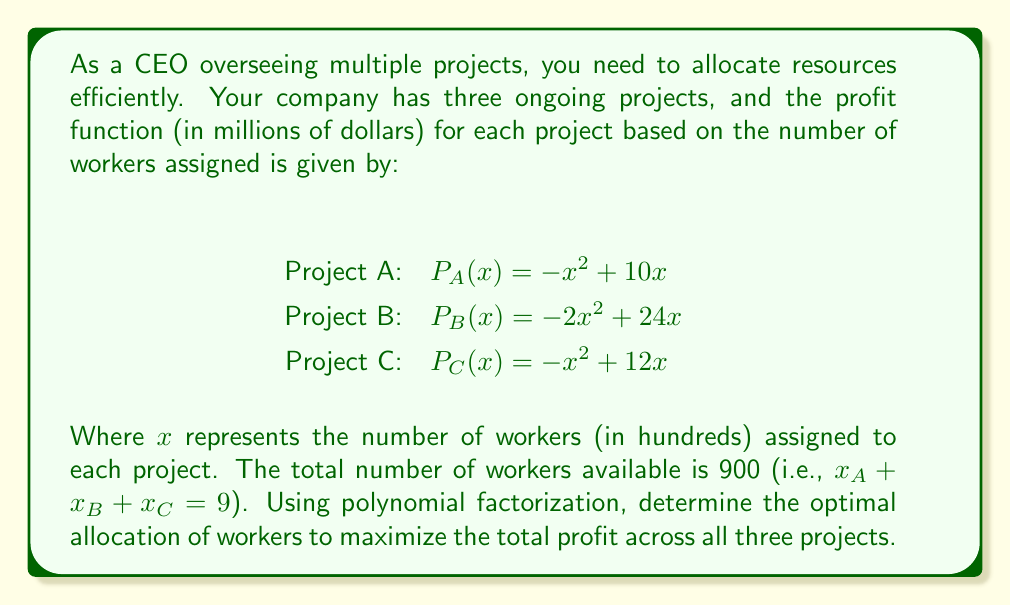Solve this math problem. To solve this problem, we'll follow these steps:

1) First, we need to create a function for the total profit:
   $P_{total}(x_A, x_B, x_C) = P_A(x_A) + P_B(x_B) + P_C(x_C)$
   $= (-x_A^2 + 10x_A) + (-2x_B^2 + 24x_B) + (-x_C^2 + 12x_C)$

2) We know that $x_A + x_B + x_C = 9$, so we can substitute $x_C = 9 - x_A - x_B$:
   $P_{total}(x_A, x_B) = (-x_A^2 + 10x_A) + (-2x_B^2 + 24x_B) + (-(9-x_A-x_B)^2 + 12(9-x_A-x_B))$

3) Expand this equation:
   $P_{total}(x_A, x_B) = -x_A^2 + 10x_A - 2x_B^2 + 24x_B - (81 - 18x_A - 18x_B + x_A^2 + 2x_Ax_B + x_B^2) + 108 - 12x_A - 12x_B$

4) Simplify:
   $P_{total}(x_A, x_B) = -2x_A^2 - 3x_B^2 - 2x_Ax_B + 16x_A + 30x_B + 27$

5) To find the maximum, we need to find where the partial derivatives are zero:
   $\frac{\partial P}{\partial x_A} = -4x_A - 2x_B + 16 = 0$
   $\frac{\partial P}{\partial x_B} = -6x_B - 2x_A + 30 = 0$

6) Solve this system of equations:
   From the first equation: $x_A = 4 - \frac{1}{2}x_B$
   Substitute into the second equation:
   $-6x_B - 2(4 - \frac{1}{2}x_B) + 30 = 0$
   $-6x_B - 8 + x_B + 30 = 0$
   $-5x_B + 22 = 0$
   $x_B = \frac{22}{5} = 4.4$

   Substitute back to find $x_A$:
   $x_A = 4 - \frac{1}{2}(4.4) = 1.8$

   And remember $x_C = 9 - x_A - x_B = 9 - 1.8 - 4.4 = 2.8$

7) To verify this is a maximum, we could check the second derivatives, but given the problem context, this solution makes sense.

Therefore, the optimal allocation is:
Project A: 180 workers
Project B: 440 workers
Project C: 280 workers
Answer: The optimal allocation to maximize total profit is:
Project A: 180 workers
Project B: 440 workers
Project C: 280 workers 